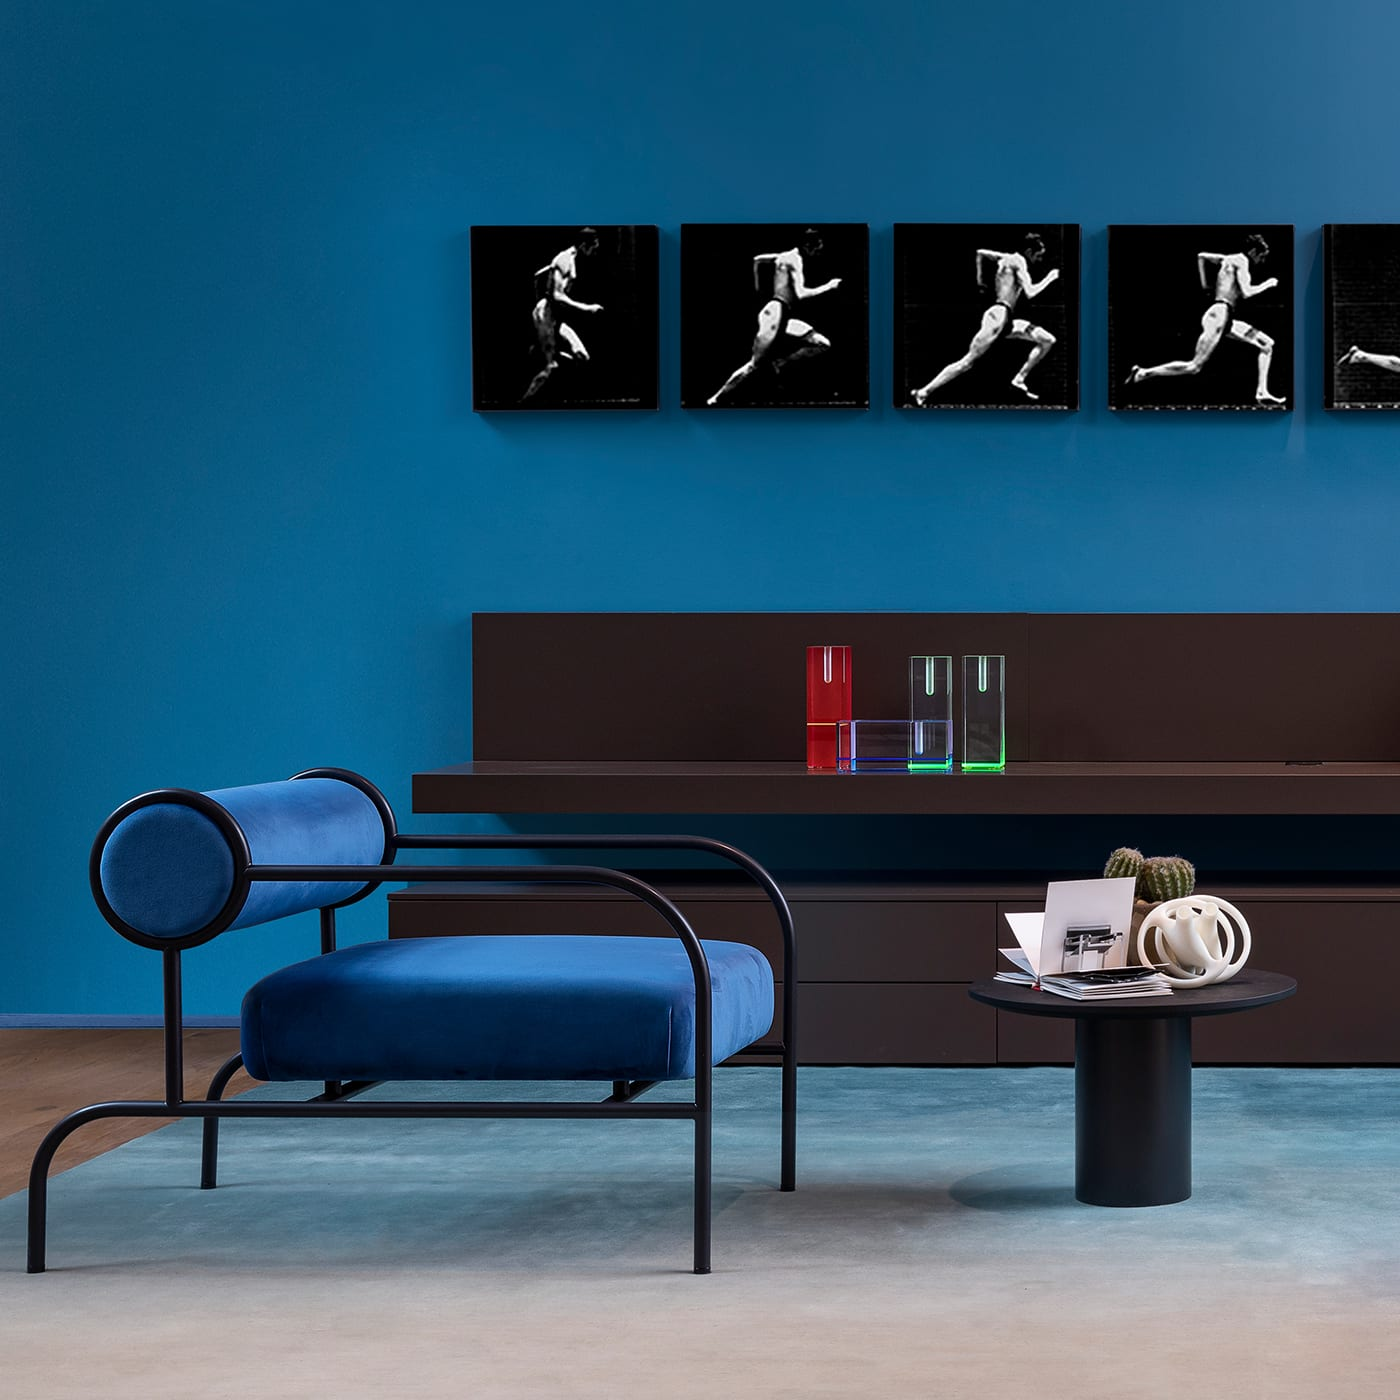What style is the furniture in this image? The furniture in the image is designed in a modern contemporary style, characterized by clean lines and a minimalist aesthetic with a striking blue upholstered lounge chair and a sleek, dark oval coffee table. 